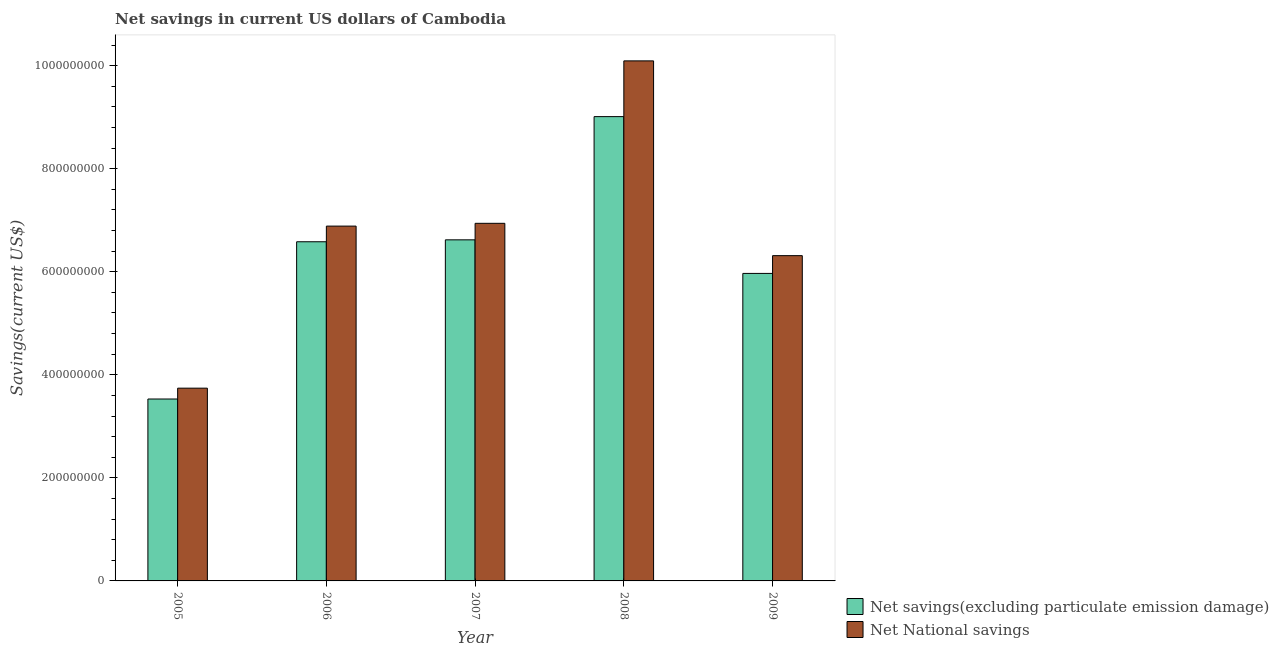How many different coloured bars are there?
Your answer should be compact. 2. How many groups of bars are there?
Offer a terse response. 5. How many bars are there on the 4th tick from the left?
Your response must be concise. 2. In how many cases, is the number of bars for a given year not equal to the number of legend labels?
Give a very brief answer. 0. What is the net savings(excluding particulate emission damage) in 2007?
Your answer should be compact. 6.62e+08. Across all years, what is the maximum net savings(excluding particulate emission damage)?
Keep it short and to the point. 9.01e+08. Across all years, what is the minimum net national savings?
Provide a short and direct response. 3.74e+08. What is the total net national savings in the graph?
Your answer should be very brief. 3.40e+09. What is the difference between the net savings(excluding particulate emission damage) in 2007 and that in 2009?
Your response must be concise. 6.52e+07. What is the difference between the net savings(excluding particulate emission damage) in 2009 and the net national savings in 2008?
Your answer should be very brief. -3.04e+08. What is the average net savings(excluding particulate emission damage) per year?
Offer a terse response. 6.34e+08. In the year 2007, what is the difference between the net savings(excluding particulate emission damage) and net national savings?
Your answer should be very brief. 0. In how many years, is the net national savings greater than 920000000 US$?
Offer a very short reply. 1. What is the ratio of the net savings(excluding particulate emission damage) in 2005 to that in 2006?
Provide a short and direct response. 0.54. Is the difference between the net national savings in 2007 and 2008 greater than the difference between the net savings(excluding particulate emission damage) in 2007 and 2008?
Offer a terse response. No. What is the difference between the highest and the second highest net national savings?
Offer a terse response. 3.15e+08. What is the difference between the highest and the lowest net savings(excluding particulate emission damage)?
Your response must be concise. 5.48e+08. In how many years, is the net national savings greater than the average net national savings taken over all years?
Ensure brevity in your answer.  3. Is the sum of the net savings(excluding particulate emission damage) in 2007 and 2009 greater than the maximum net national savings across all years?
Your answer should be compact. Yes. What does the 1st bar from the left in 2005 represents?
Your response must be concise. Net savings(excluding particulate emission damage). What does the 1st bar from the right in 2009 represents?
Provide a succinct answer. Net National savings. How many bars are there?
Ensure brevity in your answer.  10. Does the graph contain grids?
Your response must be concise. No. Where does the legend appear in the graph?
Offer a very short reply. Bottom right. How many legend labels are there?
Make the answer very short. 2. What is the title of the graph?
Ensure brevity in your answer.  Net savings in current US dollars of Cambodia. What is the label or title of the Y-axis?
Make the answer very short. Savings(current US$). What is the Savings(current US$) in Net savings(excluding particulate emission damage) in 2005?
Your response must be concise. 3.53e+08. What is the Savings(current US$) in Net National savings in 2005?
Ensure brevity in your answer.  3.74e+08. What is the Savings(current US$) of Net savings(excluding particulate emission damage) in 2006?
Offer a very short reply. 6.58e+08. What is the Savings(current US$) of Net National savings in 2006?
Your answer should be compact. 6.89e+08. What is the Savings(current US$) of Net savings(excluding particulate emission damage) in 2007?
Offer a terse response. 6.62e+08. What is the Savings(current US$) of Net National savings in 2007?
Ensure brevity in your answer.  6.94e+08. What is the Savings(current US$) of Net savings(excluding particulate emission damage) in 2008?
Give a very brief answer. 9.01e+08. What is the Savings(current US$) of Net National savings in 2008?
Provide a short and direct response. 1.01e+09. What is the Savings(current US$) in Net savings(excluding particulate emission damage) in 2009?
Offer a very short reply. 5.97e+08. What is the Savings(current US$) in Net National savings in 2009?
Offer a very short reply. 6.31e+08. Across all years, what is the maximum Savings(current US$) of Net savings(excluding particulate emission damage)?
Keep it short and to the point. 9.01e+08. Across all years, what is the maximum Savings(current US$) of Net National savings?
Your answer should be compact. 1.01e+09. Across all years, what is the minimum Savings(current US$) in Net savings(excluding particulate emission damage)?
Keep it short and to the point. 3.53e+08. Across all years, what is the minimum Savings(current US$) of Net National savings?
Offer a very short reply. 3.74e+08. What is the total Savings(current US$) in Net savings(excluding particulate emission damage) in the graph?
Keep it short and to the point. 3.17e+09. What is the total Savings(current US$) in Net National savings in the graph?
Make the answer very short. 3.40e+09. What is the difference between the Savings(current US$) in Net savings(excluding particulate emission damage) in 2005 and that in 2006?
Offer a terse response. -3.05e+08. What is the difference between the Savings(current US$) of Net National savings in 2005 and that in 2006?
Your answer should be very brief. -3.15e+08. What is the difference between the Savings(current US$) in Net savings(excluding particulate emission damage) in 2005 and that in 2007?
Provide a short and direct response. -3.09e+08. What is the difference between the Savings(current US$) of Net National savings in 2005 and that in 2007?
Your answer should be very brief. -3.20e+08. What is the difference between the Savings(current US$) of Net savings(excluding particulate emission damage) in 2005 and that in 2008?
Ensure brevity in your answer.  -5.48e+08. What is the difference between the Savings(current US$) in Net National savings in 2005 and that in 2008?
Provide a short and direct response. -6.35e+08. What is the difference between the Savings(current US$) of Net savings(excluding particulate emission damage) in 2005 and that in 2009?
Make the answer very short. -2.44e+08. What is the difference between the Savings(current US$) of Net National savings in 2005 and that in 2009?
Offer a very short reply. -2.57e+08. What is the difference between the Savings(current US$) in Net savings(excluding particulate emission damage) in 2006 and that in 2007?
Keep it short and to the point. -3.74e+06. What is the difference between the Savings(current US$) in Net National savings in 2006 and that in 2007?
Make the answer very short. -5.39e+06. What is the difference between the Savings(current US$) in Net savings(excluding particulate emission damage) in 2006 and that in 2008?
Keep it short and to the point. -2.43e+08. What is the difference between the Savings(current US$) of Net National savings in 2006 and that in 2008?
Provide a succinct answer. -3.21e+08. What is the difference between the Savings(current US$) of Net savings(excluding particulate emission damage) in 2006 and that in 2009?
Offer a terse response. 6.14e+07. What is the difference between the Savings(current US$) in Net National savings in 2006 and that in 2009?
Your answer should be very brief. 5.73e+07. What is the difference between the Savings(current US$) in Net savings(excluding particulate emission damage) in 2007 and that in 2008?
Offer a very short reply. -2.39e+08. What is the difference between the Savings(current US$) of Net National savings in 2007 and that in 2008?
Offer a terse response. -3.15e+08. What is the difference between the Savings(current US$) in Net savings(excluding particulate emission damage) in 2007 and that in 2009?
Your response must be concise. 6.52e+07. What is the difference between the Savings(current US$) in Net National savings in 2007 and that in 2009?
Ensure brevity in your answer.  6.27e+07. What is the difference between the Savings(current US$) in Net savings(excluding particulate emission damage) in 2008 and that in 2009?
Offer a very short reply. 3.04e+08. What is the difference between the Savings(current US$) in Net National savings in 2008 and that in 2009?
Your answer should be very brief. 3.78e+08. What is the difference between the Savings(current US$) of Net savings(excluding particulate emission damage) in 2005 and the Savings(current US$) of Net National savings in 2006?
Provide a succinct answer. -3.36e+08. What is the difference between the Savings(current US$) of Net savings(excluding particulate emission damage) in 2005 and the Savings(current US$) of Net National savings in 2007?
Give a very brief answer. -3.41e+08. What is the difference between the Savings(current US$) of Net savings(excluding particulate emission damage) in 2005 and the Savings(current US$) of Net National savings in 2008?
Offer a very short reply. -6.56e+08. What is the difference between the Savings(current US$) in Net savings(excluding particulate emission damage) in 2005 and the Savings(current US$) in Net National savings in 2009?
Your response must be concise. -2.78e+08. What is the difference between the Savings(current US$) in Net savings(excluding particulate emission damage) in 2006 and the Savings(current US$) in Net National savings in 2007?
Provide a short and direct response. -3.58e+07. What is the difference between the Savings(current US$) in Net savings(excluding particulate emission damage) in 2006 and the Savings(current US$) in Net National savings in 2008?
Your answer should be compact. -3.51e+08. What is the difference between the Savings(current US$) of Net savings(excluding particulate emission damage) in 2006 and the Savings(current US$) of Net National savings in 2009?
Make the answer very short. 2.69e+07. What is the difference between the Savings(current US$) of Net savings(excluding particulate emission damage) in 2007 and the Savings(current US$) of Net National savings in 2008?
Give a very brief answer. -3.47e+08. What is the difference between the Savings(current US$) in Net savings(excluding particulate emission damage) in 2007 and the Savings(current US$) in Net National savings in 2009?
Offer a very short reply. 3.07e+07. What is the difference between the Savings(current US$) in Net savings(excluding particulate emission damage) in 2008 and the Savings(current US$) in Net National savings in 2009?
Provide a short and direct response. 2.70e+08. What is the average Savings(current US$) in Net savings(excluding particulate emission damage) per year?
Your answer should be very brief. 6.34e+08. What is the average Savings(current US$) in Net National savings per year?
Provide a short and direct response. 6.79e+08. In the year 2005, what is the difference between the Savings(current US$) of Net savings(excluding particulate emission damage) and Savings(current US$) of Net National savings?
Offer a terse response. -2.11e+07. In the year 2006, what is the difference between the Savings(current US$) of Net savings(excluding particulate emission damage) and Savings(current US$) of Net National savings?
Your response must be concise. -3.04e+07. In the year 2007, what is the difference between the Savings(current US$) of Net savings(excluding particulate emission damage) and Savings(current US$) of Net National savings?
Make the answer very short. -3.20e+07. In the year 2008, what is the difference between the Savings(current US$) in Net savings(excluding particulate emission damage) and Savings(current US$) in Net National savings?
Offer a terse response. -1.08e+08. In the year 2009, what is the difference between the Savings(current US$) in Net savings(excluding particulate emission damage) and Savings(current US$) in Net National savings?
Ensure brevity in your answer.  -3.45e+07. What is the ratio of the Savings(current US$) of Net savings(excluding particulate emission damage) in 2005 to that in 2006?
Your answer should be compact. 0.54. What is the ratio of the Savings(current US$) of Net National savings in 2005 to that in 2006?
Make the answer very short. 0.54. What is the ratio of the Savings(current US$) in Net savings(excluding particulate emission damage) in 2005 to that in 2007?
Give a very brief answer. 0.53. What is the ratio of the Savings(current US$) of Net National savings in 2005 to that in 2007?
Offer a terse response. 0.54. What is the ratio of the Savings(current US$) in Net savings(excluding particulate emission damage) in 2005 to that in 2008?
Make the answer very short. 0.39. What is the ratio of the Savings(current US$) in Net National savings in 2005 to that in 2008?
Make the answer very short. 0.37. What is the ratio of the Savings(current US$) in Net savings(excluding particulate emission damage) in 2005 to that in 2009?
Keep it short and to the point. 0.59. What is the ratio of the Savings(current US$) in Net National savings in 2005 to that in 2009?
Provide a short and direct response. 0.59. What is the ratio of the Savings(current US$) of Net National savings in 2006 to that in 2007?
Ensure brevity in your answer.  0.99. What is the ratio of the Savings(current US$) of Net savings(excluding particulate emission damage) in 2006 to that in 2008?
Offer a very short reply. 0.73. What is the ratio of the Savings(current US$) of Net National savings in 2006 to that in 2008?
Make the answer very short. 0.68. What is the ratio of the Savings(current US$) in Net savings(excluding particulate emission damage) in 2006 to that in 2009?
Your response must be concise. 1.1. What is the ratio of the Savings(current US$) in Net National savings in 2006 to that in 2009?
Your answer should be very brief. 1.09. What is the ratio of the Savings(current US$) of Net savings(excluding particulate emission damage) in 2007 to that in 2008?
Offer a terse response. 0.73. What is the ratio of the Savings(current US$) of Net National savings in 2007 to that in 2008?
Your answer should be compact. 0.69. What is the ratio of the Savings(current US$) of Net savings(excluding particulate emission damage) in 2007 to that in 2009?
Ensure brevity in your answer.  1.11. What is the ratio of the Savings(current US$) of Net National savings in 2007 to that in 2009?
Keep it short and to the point. 1.1. What is the ratio of the Savings(current US$) of Net savings(excluding particulate emission damage) in 2008 to that in 2009?
Make the answer very short. 1.51. What is the ratio of the Savings(current US$) of Net National savings in 2008 to that in 2009?
Offer a terse response. 1.6. What is the difference between the highest and the second highest Savings(current US$) of Net savings(excluding particulate emission damage)?
Keep it short and to the point. 2.39e+08. What is the difference between the highest and the second highest Savings(current US$) of Net National savings?
Ensure brevity in your answer.  3.15e+08. What is the difference between the highest and the lowest Savings(current US$) in Net savings(excluding particulate emission damage)?
Your response must be concise. 5.48e+08. What is the difference between the highest and the lowest Savings(current US$) of Net National savings?
Offer a very short reply. 6.35e+08. 